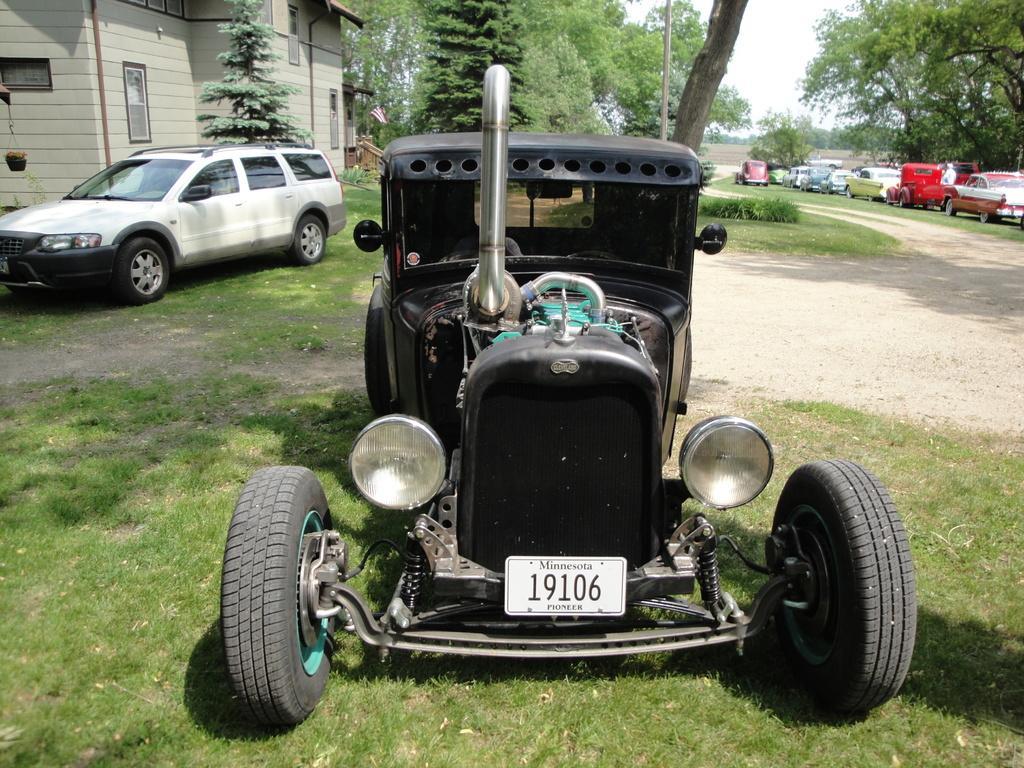Describe this image in one or two sentences. In this image we can see a vehicle on the grassy land. In the background, we can see trees, building, flag, a car and the sky. On the right side of the image, we can see the cars. 